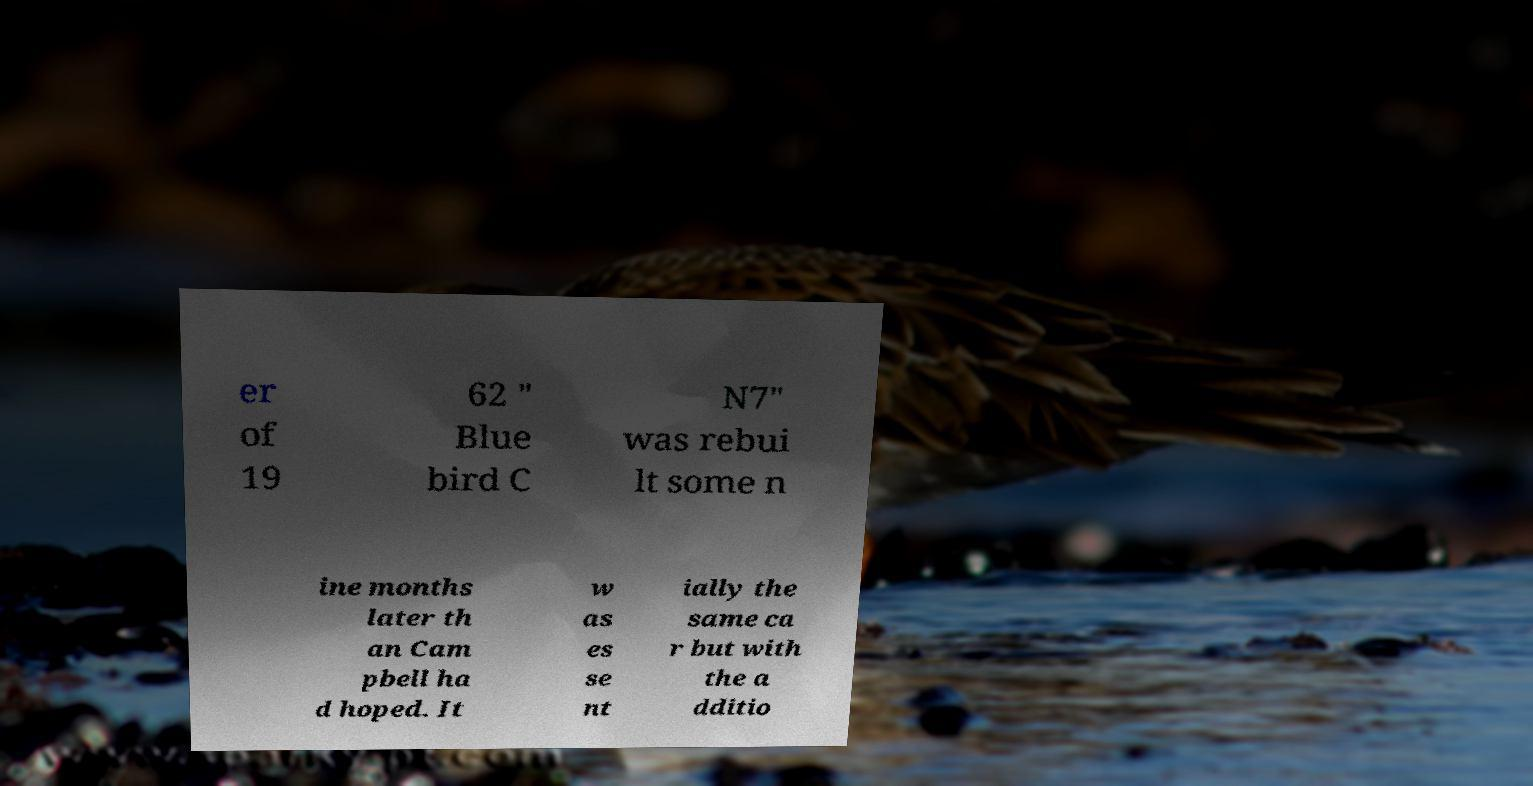There's text embedded in this image that I need extracted. Can you transcribe it verbatim? er of 19 62 " Blue bird C N7" was rebui lt some n ine months later th an Cam pbell ha d hoped. It w as es se nt ially the same ca r but with the a dditio 